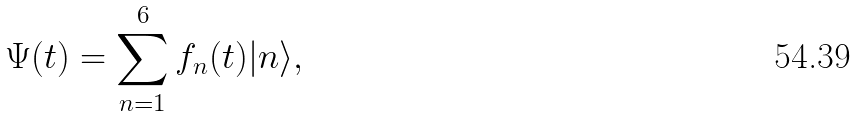Convert formula to latex. <formula><loc_0><loc_0><loc_500><loc_500>\Psi ( t ) = \sum _ { n = 1 } ^ { 6 } f _ { n } ( t ) | n \rangle ,</formula> 